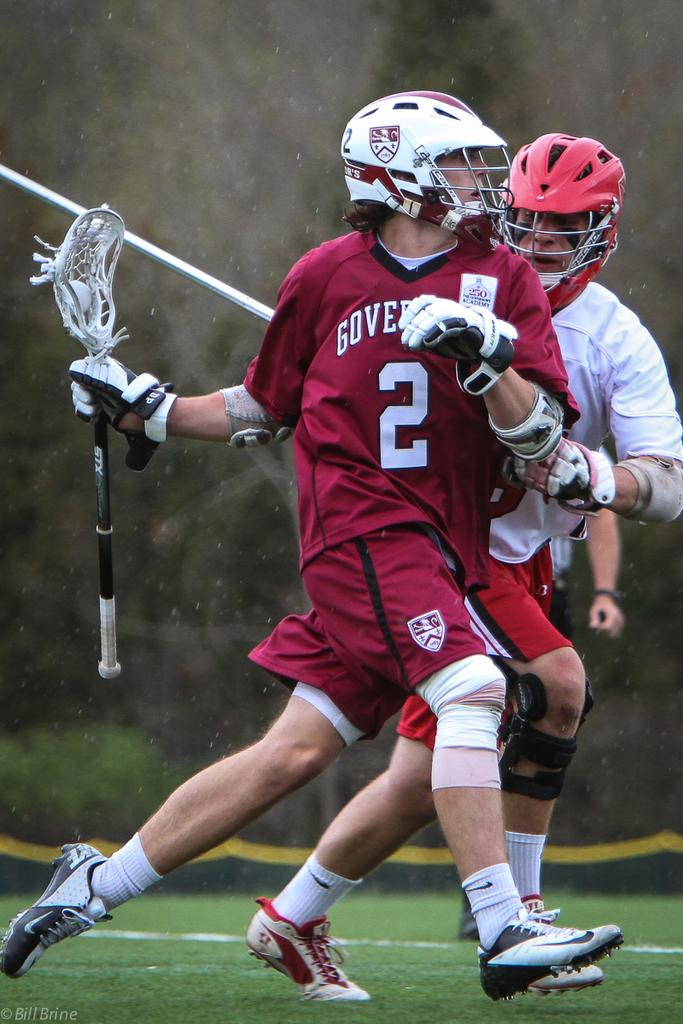Provide a one-sentence caption for the provided image. An athlete wearing a number 2 jersey tries to escape his blocker. 